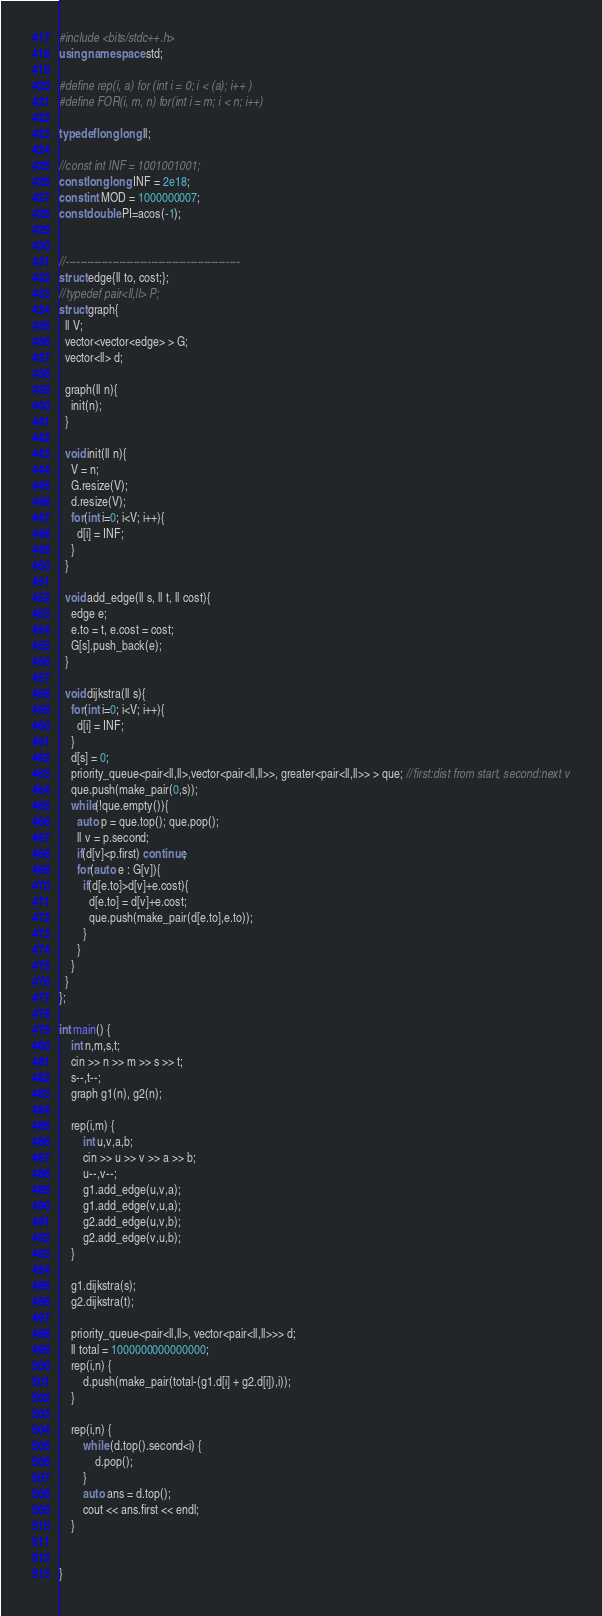<code> <loc_0><loc_0><loc_500><loc_500><_C++_>#include <bits/stdc++.h>
using namespace std;

#define rep(i, a) for (int i = 0; i < (a); i++ )
#define FOR(i, m, n) for(int i = m; i < n; i++)
 
typedef long long ll;
 
//const int INF = 1001001001;
const long long INF = 2e18;
const int MOD = 1000000007;
const double PI=acos(-1);


//-------------------------------------------------
struct edge{ll to, cost;};
//typedef pair<ll,ll> P;
struct graph{
  ll V;
  vector<vector<edge> > G;
  vector<ll> d;

  graph(ll n){
    init(n);
  }

  void init(ll n){
    V = n;
    G.resize(V);
    d.resize(V);
    for(int i=0; i<V; i++){
      d[i] = INF;
    }
  }

  void add_edge(ll s, ll t, ll cost){
    edge e;
    e.to = t, e.cost = cost;
    G[s].push_back(e);
  }

  void dijkstra(ll s){
    for(int i=0; i<V; i++){
      d[i] = INF;
    }
    d[s] = 0;
    priority_queue<pair<ll,ll>,vector<pair<ll,ll>>, greater<pair<ll,ll>> > que; //first:dist from start, second:next v
    que.push(make_pair(0,s));
    while(!que.empty()){
      auto p = que.top(); que.pop();
      ll v = p.second;
      if(d[v]<p.first) continue;
      for(auto e : G[v]){
        if(d[e.to]>d[v]+e.cost){
          d[e.to] = d[v]+e.cost;
          que.push(make_pair(d[e.to],e.to));
        }
      }
    }
  }
};

int main() {
    int n,m,s,t;
    cin >> n >> m >> s >> t;
    s--,t--;
    graph g1(n), g2(n);

    rep(i,m) {
        int u,v,a,b;
        cin >> u >> v >> a >> b;
        u--,v--;
        g1.add_edge(u,v,a);
        g1.add_edge(v,u,a);
        g2.add_edge(u,v,b);
        g2.add_edge(v,u,b);
    }
    
    g1.dijkstra(s);
    g2.dijkstra(t);

    priority_queue<pair<ll,ll>, vector<pair<ll,ll>>> d;
    ll total = 1000000000000000;
    rep(i,n) {
        d.push(make_pair(total-(g1.d[i] + g2.d[i]),i));
    }

    rep(i,n) {
        while (d.top().second<i) {
            d.pop();
        }
        auto ans = d.top();
        cout << ans.first << endl;
    }


}</code> 